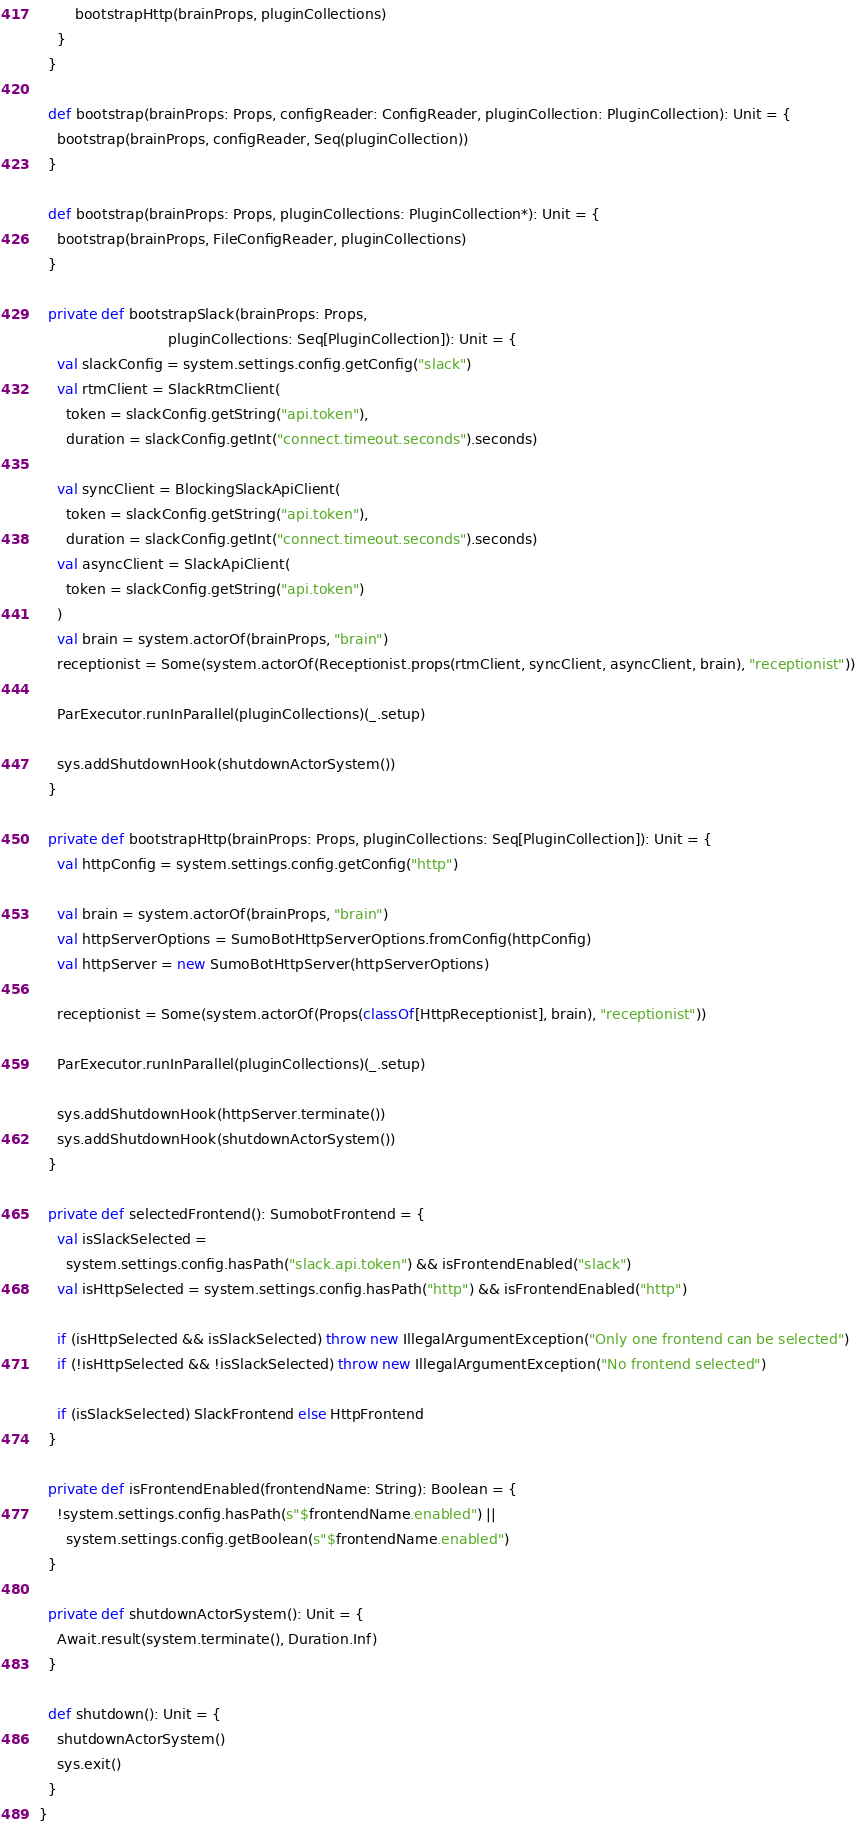<code> <loc_0><loc_0><loc_500><loc_500><_Scala_>        bootstrapHttp(brainProps, pluginCollections)
    }
  }

  def bootstrap(brainProps: Props, configReader: ConfigReader, pluginCollection: PluginCollection): Unit = {
    bootstrap(brainProps, configReader, Seq(pluginCollection))
  }

  def bootstrap(brainProps: Props, pluginCollections: PluginCollection*): Unit = {
    bootstrap(brainProps, FileConfigReader, pluginCollections)
  }

  private def bootstrapSlack(brainProps: Props,
                             pluginCollections: Seq[PluginCollection]): Unit = {
    val slackConfig = system.settings.config.getConfig("slack")
    val rtmClient = SlackRtmClient(
      token = slackConfig.getString("api.token"),
      duration = slackConfig.getInt("connect.timeout.seconds").seconds)

    val syncClient = BlockingSlackApiClient(
      token = slackConfig.getString("api.token"),
      duration = slackConfig.getInt("connect.timeout.seconds").seconds)
    val asyncClient = SlackApiClient(
      token = slackConfig.getString("api.token")
    )
    val brain = system.actorOf(brainProps, "brain")
    receptionist = Some(system.actorOf(Receptionist.props(rtmClient, syncClient, asyncClient, brain), "receptionist"))

    ParExecutor.runInParallel(pluginCollections)(_.setup)

    sys.addShutdownHook(shutdownActorSystem())
  }

  private def bootstrapHttp(brainProps: Props, pluginCollections: Seq[PluginCollection]): Unit = {
    val httpConfig = system.settings.config.getConfig("http")

    val brain = system.actorOf(brainProps, "brain")
    val httpServerOptions = SumoBotHttpServerOptions.fromConfig(httpConfig)
    val httpServer = new SumoBotHttpServer(httpServerOptions)

    receptionist = Some(system.actorOf(Props(classOf[HttpReceptionist], brain), "receptionist"))

    ParExecutor.runInParallel(pluginCollections)(_.setup)

    sys.addShutdownHook(httpServer.terminate())
    sys.addShutdownHook(shutdownActorSystem())
  }

  private def selectedFrontend(): SumobotFrontend = {
    val isSlackSelected =
      system.settings.config.hasPath("slack.api.token") && isFrontendEnabled("slack")
    val isHttpSelected = system.settings.config.hasPath("http") && isFrontendEnabled("http")

    if (isHttpSelected && isSlackSelected) throw new IllegalArgumentException("Only one frontend can be selected")
    if (!isHttpSelected && !isSlackSelected) throw new IllegalArgumentException("No frontend selected")

    if (isSlackSelected) SlackFrontend else HttpFrontend
  }

  private def isFrontendEnabled(frontendName: String): Boolean = {
    !system.settings.config.hasPath(s"$frontendName.enabled") ||
      system.settings.config.getBoolean(s"$frontendName.enabled")
  }

  private def shutdownActorSystem(): Unit = {
    Await.result(system.terminate(), Duration.Inf)
  }

  def shutdown(): Unit = {
    shutdownActorSystem()
    sys.exit()
  }
}
</code> 